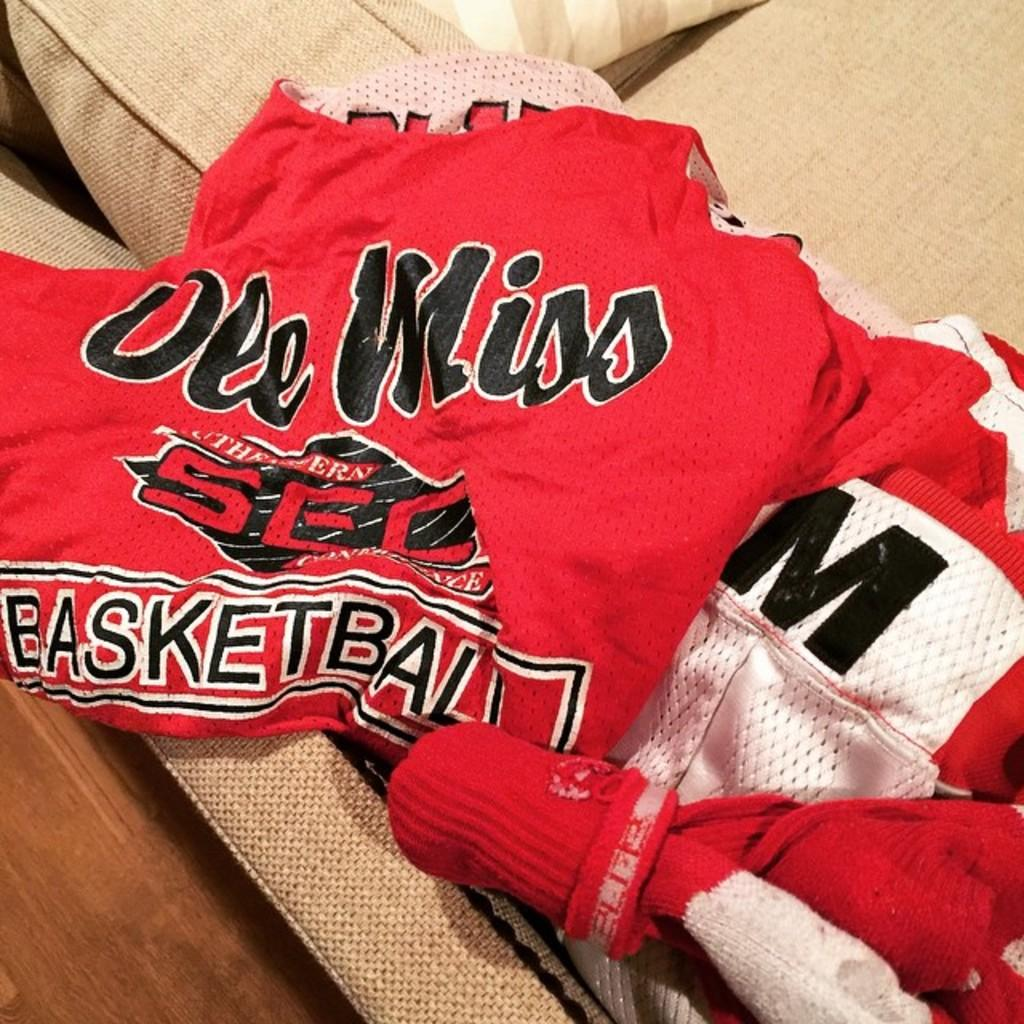Provide a one-sentence caption for the provided image. An Ole Miss basketball jersey is laying on a couch. 